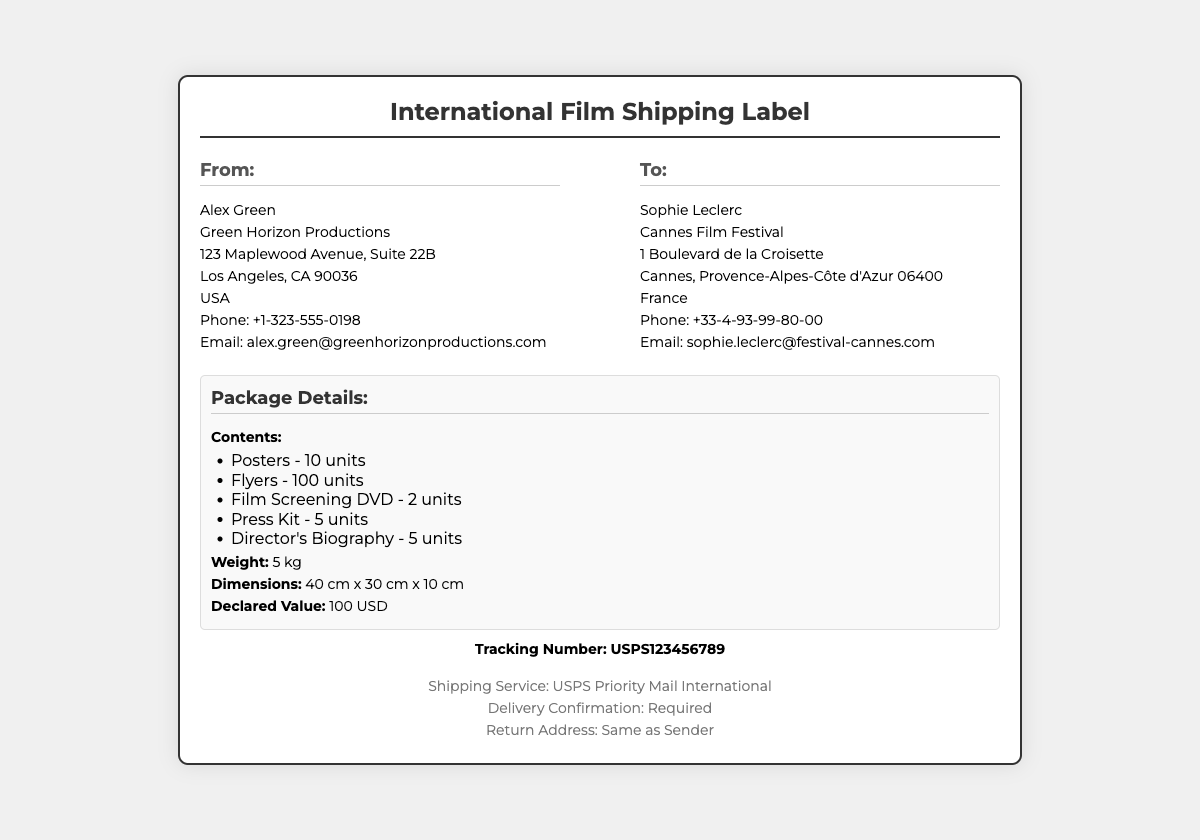What is the name of the sender? The sender's name is listed in the document as Alex Green.
Answer: Alex Green What is the name of the receiver? The receiver's name is given as Sophie Leclerc.
Answer: Sophie Leclerc What is the shipping service used? The document specifies that the shipping service used is USPS Priority Mail International.
Answer: USPS Priority Mail International What is the declared value of the package? The declared value is explicitly stated in the document as 100 USD.
Answer: 100 USD How many film screening DVDs are included? The number of film screening DVDs is listed as 2 units.
Answer: 2 units What is the weight of the package? The weight of the package is mentioned as 5 kg.
Answer: 5 kg What is the tracking number? The tracking number is provided in the document as USPS123456789.
Answer: USPS123456789 Is delivery confirmation required? The document states that delivery confirmation is required.
Answer: Required What is the return address? The return address is specified to be the same as the sender's address.
Answer: Same as Sender 